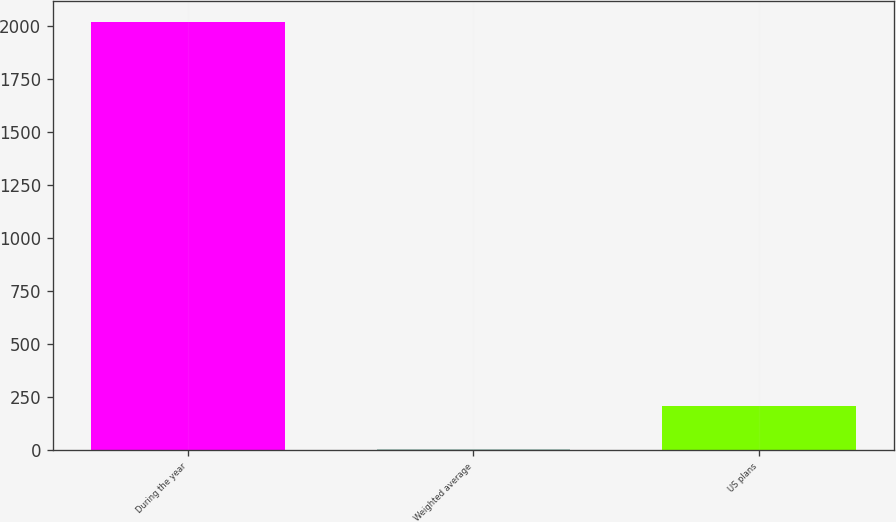Convert chart to OTSL. <chart><loc_0><loc_0><loc_500><loc_500><bar_chart><fcel>During the year<fcel>Weighted average<fcel>US plans<nl><fcel>2016<fcel>4.76<fcel>205.88<nl></chart> 